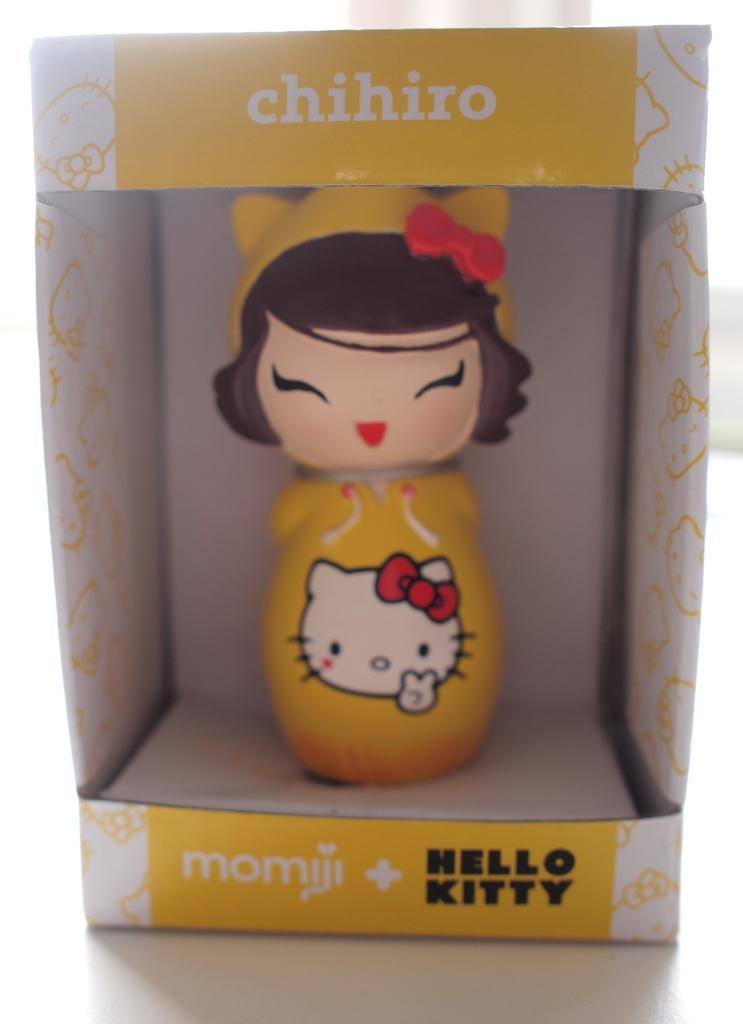What type of toy is in the image? There is a girl toy in the image. Where is the girl toy located? The girl toy is in a box. What is the box resting on in the image? The box is on a surface. What type of cake is being served at the girl toy's birthday party in the image? There is no cake or birthday party present in the image; it only features a girl toy in a box on a surface. 